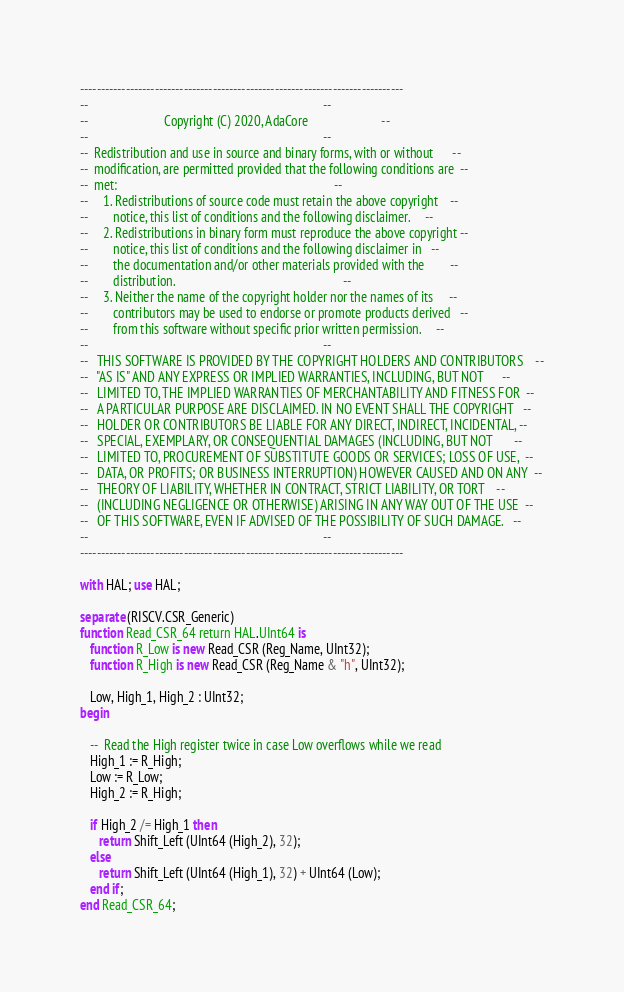<code> <loc_0><loc_0><loc_500><loc_500><_Ada_>------------------------------------------------------------------------------
--                                                                          --
--                        Copyright (C) 2020, AdaCore                       --
--                                                                          --
--  Redistribution and use in source and binary forms, with or without      --
--  modification, are permitted provided that the following conditions are  --
--  met:                                                                    --
--     1. Redistributions of source code must retain the above copyright    --
--        notice, this list of conditions and the following disclaimer.     --
--     2. Redistributions in binary form must reproduce the above copyright --
--        notice, this list of conditions and the following disclaimer in   --
--        the documentation and/or other materials provided with the        --
--        distribution.                                                     --
--     3. Neither the name of the copyright holder nor the names of its     --
--        contributors may be used to endorse or promote products derived   --
--        from this software without specific prior written permission.     --
--                                                                          --
--   THIS SOFTWARE IS PROVIDED BY THE COPYRIGHT HOLDERS AND CONTRIBUTORS    --
--   "AS IS" AND ANY EXPRESS OR IMPLIED WARRANTIES, INCLUDING, BUT NOT      --
--   LIMITED TO, THE IMPLIED WARRANTIES OF MERCHANTABILITY AND FITNESS FOR  --
--   A PARTICULAR PURPOSE ARE DISCLAIMED. IN NO EVENT SHALL THE COPYRIGHT   --
--   HOLDER OR CONTRIBUTORS BE LIABLE FOR ANY DIRECT, INDIRECT, INCIDENTAL, --
--   SPECIAL, EXEMPLARY, OR CONSEQUENTIAL DAMAGES (INCLUDING, BUT NOT       --
--   LIMITED TO, PROCUREMENT OF SUBSTITUTE GOODS OR SERVICES; LOSS OF USE,  --
--   DATA, OR PROFITS; OR BUSINESS INTERRUPTION) HOWEVER CAUSED AND ON ANY  --
--   THEORY OF LIABILITY, WHETHER IN CONTRACT, STRICT LIABILITY, OR TORT    --
--   (INCLUDING NEGLIGENCE OR OTHERWISE) ARISING IN ANY WAY OUT OF THE USE  --
--   OF THIS SOFTWARE, EVEN IF ADVISED OF THE POSSIBILITY OF SUCH DAMAGE.   --
--                                                                          --
------------------------------------------------------------------------------

with HAL; use HAL;

separate (RISCV.CSR_Generic)
function Read_CSR_64 return HAL.UInt64 is
   function R_Low is new Read_CSR (Reg_Name, UInt32);
   function R_High is new Read_CSR (Reg_Name & "h", UInt32);

   Low, High_1, High_2 : UInt32;
begin

   --  Read the High register twice in case Low overflows while we read
   High_1 := R_High;
   Low := R_Low;
   High_2 := R_High;

   if High_2 /= High_1 then
      return Shift_Left (UInt64 (High_2), 32);
   else
      return Shift_Left (UInt64 (High_1), 32) + UInt64 (Low);
   end if;
end Read_CSR_64;
</code> 